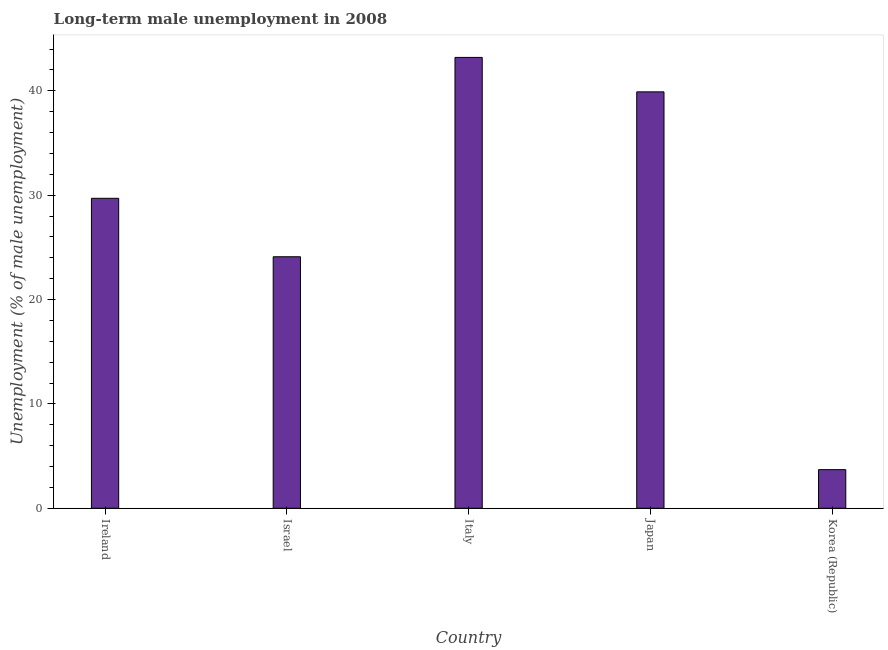Does the graph contain any zero values?
Make the answer very short. No. What is the title of the graph?
Ensure brevity in your answer.  Long-term male unemployment in 2008. What is the label or title of the X-axis?
Your response must be concise. Country. What is the label or title of the Y-axis?
Provide a short and direct response. Unemployment (% of male unemployment). What is the long-term male unemployment in Japan?
Your answer should be compact. 39.9. Across all countries, what is the maximum long-term male unemployment?
Offer a very short reply. 43.2. Across all countries, what is the minimum long-term male unemployment?
Give a very brief answer. 3.7. In which country was the long-term male unemployment minimum?
Make the answer very short. Korea (Republic). What is the sum of the long-term male unemployment?
Your answer should be very brief. 140.6. What is the difference between the long-term male unemployment in Japan and Korea (Republic)?
Offer a terse response. 36.2. What is the average long-term male unemployment per country?
Ensure brevity in your answer.  28.12. What is the median long-term male unemployment?
Offer a terse response. 29.7. What is the ratio of the long-term male unemployment in Israel to that in Korea (Republic)?
Your answer should be compact. 6.51. Is the long-term male unemployment in Ireland less than that in Israel?
Your answer should be very brief. No. What is the difference between the highest and the lowest long-term male unemployment?
Keep it short and to the point. 39.5. How many bars are there?
Provide a succinct answer. 5. Are all the bars in the graph horizontal?
Offer a terse response. No. What is the difference between two consecutive major ticks on the Y-axis?
Keep it short and to the point. 10. What is the Unemployment (% of male unemployment) of Ireland?
Offer a very short reply. 29.7. What is the Unemployment (% of male unemployment) of Israel?
Ensure brevity in your answer.  24.1. What is the Unemployment (% of male unemployment) in Italy?
Your answer should be compact. 43.2. What is the Unemployment (% of male unemployment) in Japan?
Ensure brevity in your answer.  39.9. What is the Unemployment (% of male unemployment) of Korea (Republic)?
Provide a short and direct response. 3.7. What is the difference between the Unemployment (% of male unemployment) in Ireland and Israel?
Provide a succinct answer. 5.6. What is the difference between the Unemployment (% of male unemployment) in Ireland and Japan?
Your answer should be compact. -10.2. What is the difference between the Unemployment (% of male unemployment) in Ireland and Korea (Republic)?
Provide a succinct answer. 26. What is the difference between the Unemployment (% of male unemployment) in Israel and Italy?
Ensure brevity in your answer.  -19.1. What is the difference between the Unemployment (% of male unemployment) in Israel and Japan?
Offer a terse response. -15.8. What is the difference between the Unemployment (% of male unemployment) in Israel and Korea (Republic)?
Offer a terse response. 20.4. What is the difference between the Unemployment (% of male unemployment) in Italy and Japan?
Provide a short and direct response. 3.3. What is the difference between the Unemployment (% of male unemployment) in Italy and Korea (Republic)?
Ensure brevity in your answer.  39.5. What is the difference between the Unemployment (% of male unemployment) in Japan and Korea (Republic)?
Your response must be concise. 36.2. What is the ratio of the Unemployment (% of male unemployment) in Ireland to that in Israel?
Make the answer very short. 1.23. What is the ratio of the Unemployment (% of male unemployment) in Ireland to that in Italy?
Your response must be concise. 0.69. What is the ratio of the Unemployment (% of male unemployment) in Ireland to that in Japan?
Give a very brief answer. 0.74. What is the ratio of the Unemployment (% of male unemployment) in Ireland to that in Korea (Republic)?
Make the answer very short. 8.03. What is the ratio of the Unemployment (% of male unemployment) in Israel to that in Italy?
Your response must be concise. 0.56. What is the ratio of the Unemployment (% of male unemployment) in Israel to that in Japan?
Keep it short and to the point. 0.6. What is the ratio of the Unemployment (% of male unemployment) in Israel to that in Korea (Republic)?
Provide a short and direct response. 6.51. What is the ratio of the Unemployment (% of male unemployment) in Italy to that in Japan?
Ensure brevity in your answer.  1.08. What is the ratio of the Unemployment (% of male unemployment) in Italy to that in Korea (Republic)?
Provide a short and direct response. 11.68. What is the ratio of the Unemployment (% of male unemployment) in Japan to that in Korea (Republic)?
Offer a very short reply. 10.78. 